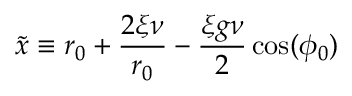<formula> <loc_0><loc_0><loc_500><loc_500>\tilde { x } \equiv r _ { 0 } + \frac { 2 \xi \nu } { r _ { 0 } } - \frac { \xi g \nu } { 2 } \cos ( \phi _ { 0 } )</formula> 